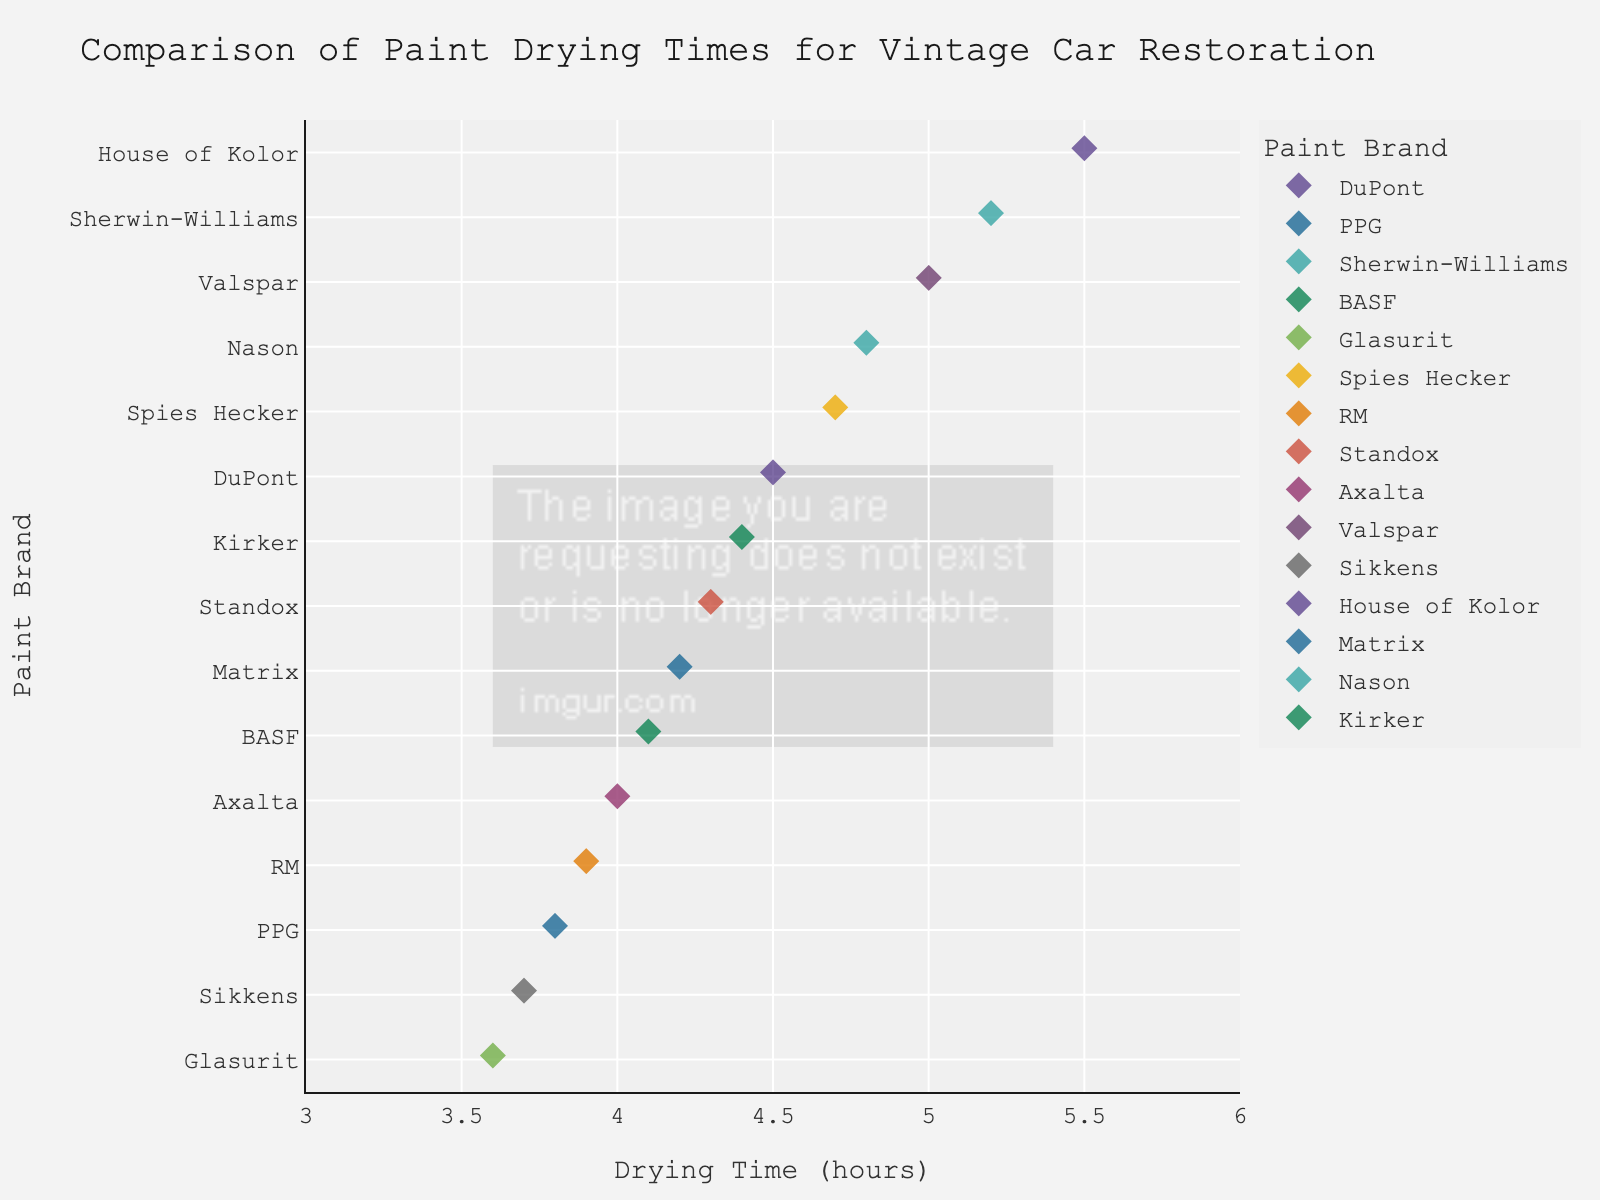What's the drying time for the brand DuPont? The drying time for DuPont is directly read from the figure.
Answer: 4.5 hours Which brand has the shortest drying time? Identify the brand with the smallest value on the x-axis.
Answer: Glasurit Which brand has the longest drying time? Identify the brand with the largest value on the x-axis.
Answer: House of Kolor What is the range of drying times for the given brands? The range is calculated by subtracting the shortest drying time from the longest drying time, i.e., 5.5 - 3.6.
Answer: 1.9 hours How many brands have a drying time below 4.0 hours? Count the number of brands with drying times less than 4.0. The brands are Glasurit, PPG, Sikkens, and RM.
Answer: 4 brands What is the average drying time for the brands displayed? Sum all drying times (4.5 + 3.8 + 5.2 + 4.1 + 3.6 + 4.7 + 3.9 + 4.3 + 4.0 + 5.0 + 3.7 + 5.5 + 4.2 + 4.8 + 4.4) and divide by the number of brands (15). The total sum is 65.7, so the average is 65.7 / 15 ≈ 4.38.
Answer: 4.38 hours Which brands have drying times between 4.0 and 5.0 hours? Identify the brands within this interval: BASF, RM, Standox, Axalta, Matrix, Nason, Kirker.
Answer: 7 brands Are there more brands with drying times above or below 4.5 hours? Count the brands above and below this threshold. Below 4.5: PPG, Glasurit, RM, Axalta, Sikkens. Above 4.5: DuPont, Sherwin-Williams, Spies Hecker, Valspar, House of Kolor, Nason, Kirker. Count and compare.
Answer: More brands above 4.5 What's the median drying time for all brands? Arrange all drying times in ascending order: 3.6, 3.7, 3.8, 3.9, 4.0, 4.1, 4.2, 4.3, 4.4, 4.5, 4.7, 4.8, 5.0, 5.2, 5.5. The median is the middle value here, which is 4.3.
Answer: 4.3 hours Are there more brands with drying times closer to 3 hours or 6 hours? Most drying times are clustered between 3.6 and 5.5 hours, so more are closer to 3 hours. Count the number close to each endpoint for clarification.
Answer: More closer to 3 hours 